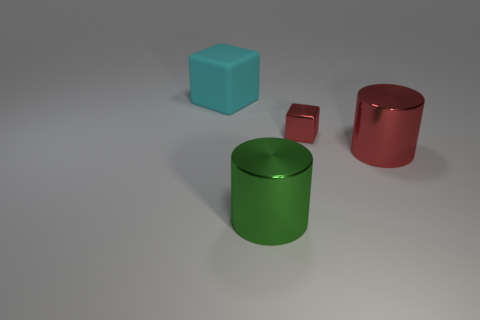Is there any other thing that is made of the same material as the cyan cube?
Your response must be concise. No. There is a red shiny object behind the large metal cylinder that is to the right of the small red metallic object; what is its size?
Offer a terse response. Small. There is a red object in front of the tiny red object; how big is it?
Offer a very short reply. Large. Are there fewer green metallic cylinders behind the red cube than big cyan objects that are to the left of the large matte thing?
Provide a short and direct response. No. What color is the shiny block?
Give a very brief answer. Red. Are there any large cylinders of the same color as the small metallic block?
Your answer should be compact. Yes. What shape is the red thing to the left of the big cylinder that is behind the big metal cylinder in front of the big red object?
Provide a succinct answer. Cube. What is the material of the block that is to the right of the big cyan rubber thing?
Offer a very short reply. Metal. What is the size of the red metal thing to the left of the large metallic cylinder that is right of the cube that is in front of the large cyan rubber thing?
Your answer should be very brief. Small. There is a rubber object; is its size the same as the block that is in front of the big cyan cube?
Your answer should be compact. No. 